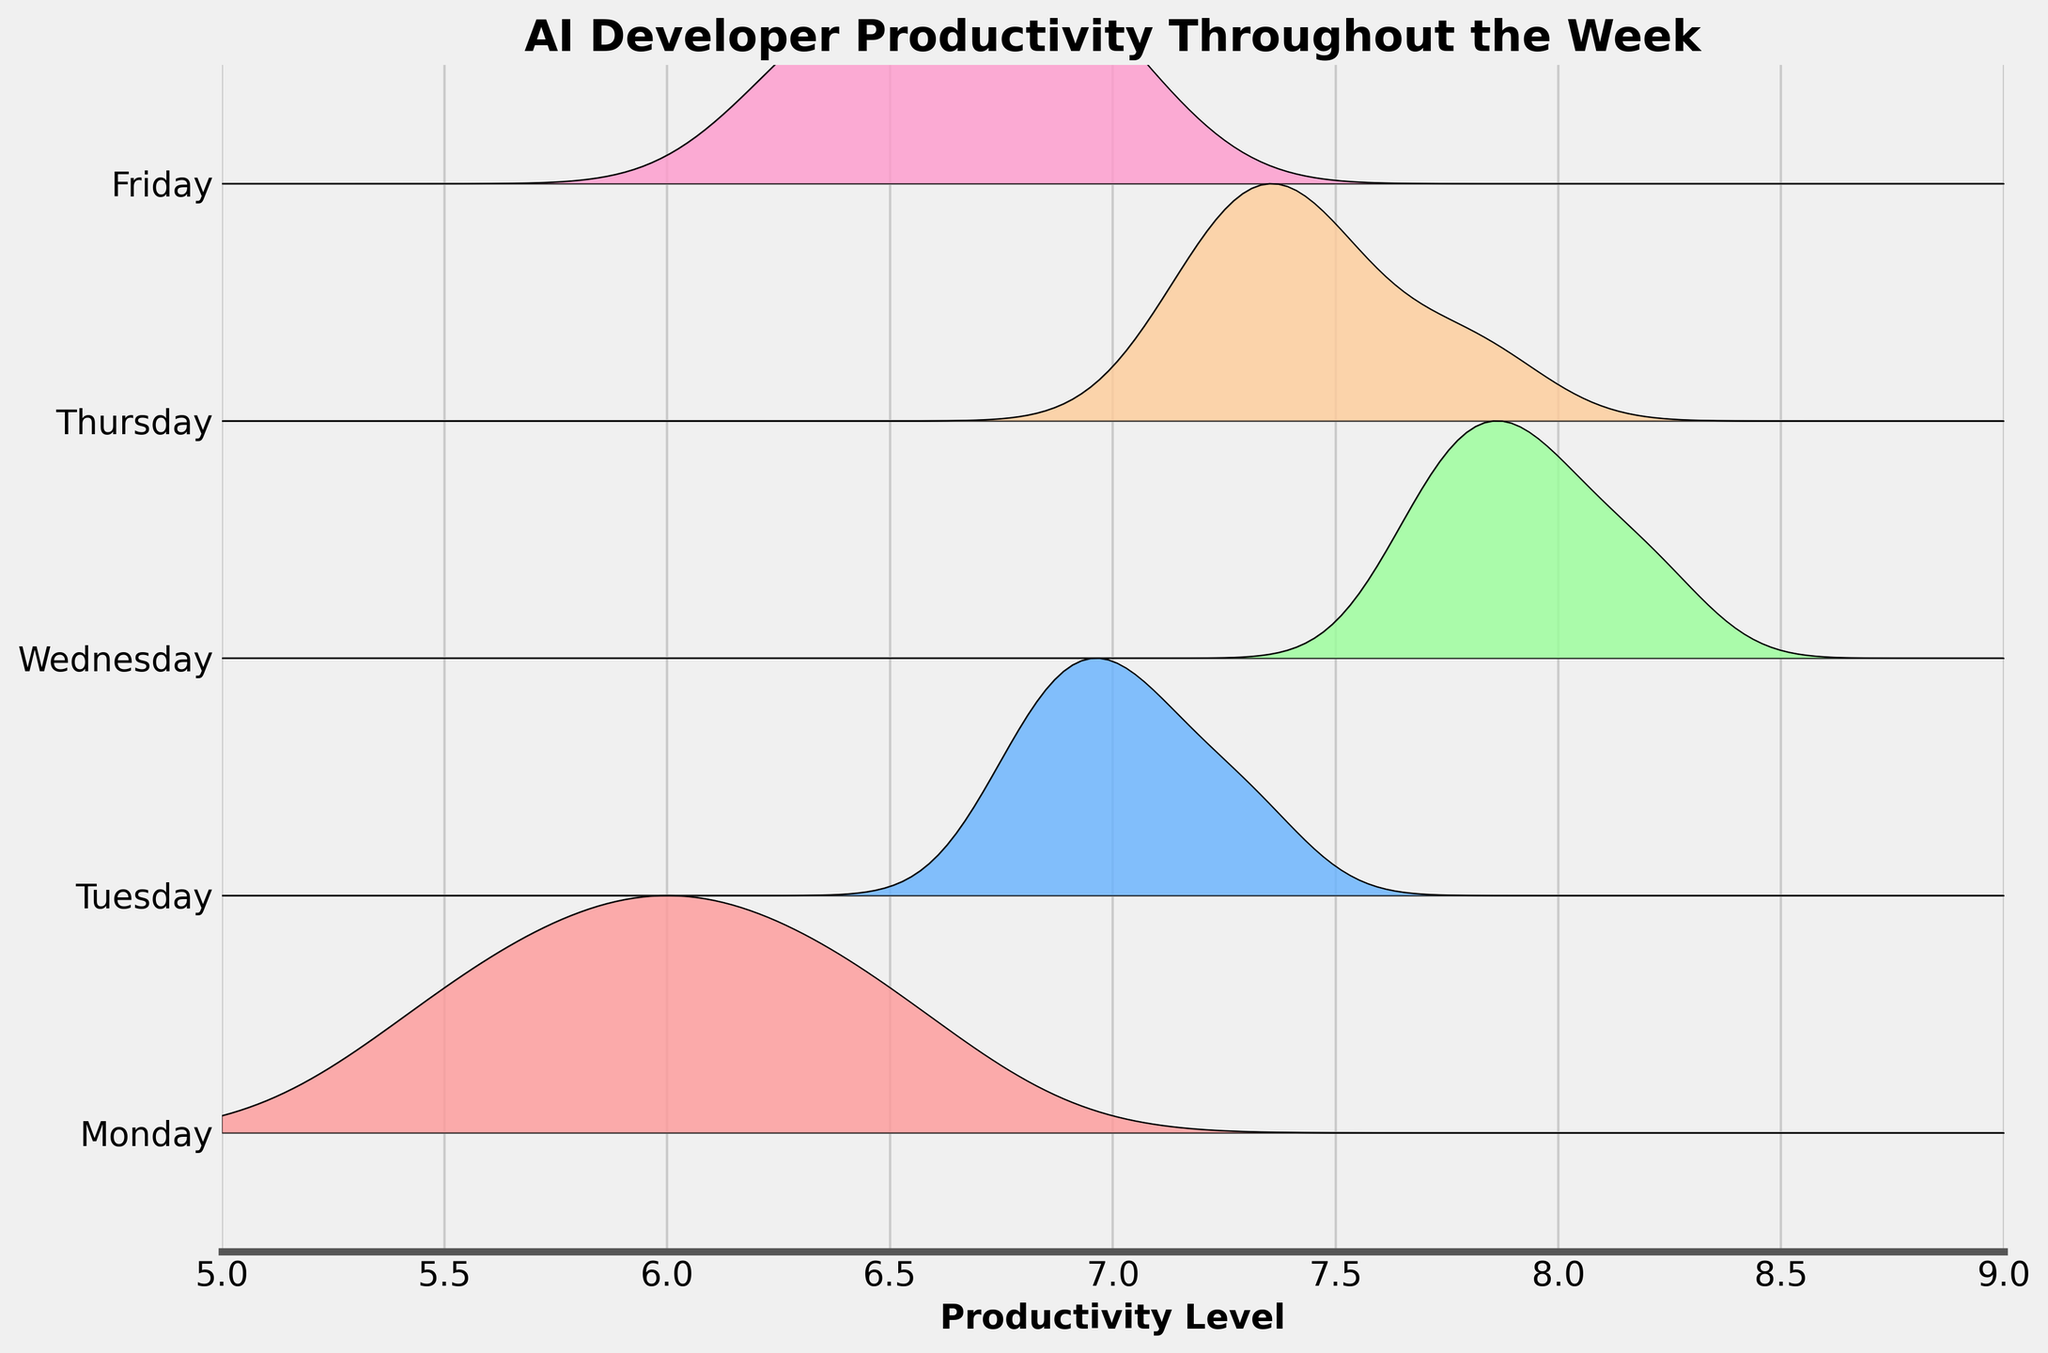What is the title of the Ridgeline plot? The title is displayed at the top of the figure, typically in a larger and bold font. It provides an overall description of what the plot represents.
Answer: AI Developer Productivity Throughout the Week What is the productivity level range represented on the x-axis? The x-axis ticks and limits define the range of productivity levels shown in the plot. Looking closely at these elements will give you the range.
Answer: 5 to 9 Which day shows the highest average productivity level? By observing the density curves and the peaks of the distributions for each day across the x-axis, we can determine which day has the overall highest productivity levels.
Answer: Wednesday What color represents the productivity levels on Tuesday? Each day is represented by a distinctive color in the plot. Looking for the color associated with the label "Tuesday" will give us the answer.
Answer: Blue (#66B2FF) Which day has the widest distribution of productivity levels? By comparing the spreads of the ridgeline plots for each day, you can determine which day has the widest range of productivity values, indicated by a broader curve.
Answer: Monday How does Friday's productivity compare to Monday's productivity? Examining the relative positions and spreads of the curves for Monday and Friday, we can compare their productivity levels. Monday's distribution appears earlier on the x-axis than Friday's.
Answer: Monday is generally lower than Friday What is the trend of average productivity from Monday to Friday? Observing the peak of the curves progressively from Monday to Friday, we can infer the trend of productivity throughout the week.
Answer: Productivity generally increases to Wednesday and then decreases towards Friday What day has the least overlap with other days in terms of productivity levels? By analyzing the density plots, we look for the curve that stands more distinctly alone without substantial overlap with other days' curves.
Answer: Wednesday What is the sharpest peak in any productivity distribution, and on what day does it occur? The sharpest peak corresponds to the highest density value of any day's curve. Identifying the day associated with this peak will provide the answer.
Answer: Wednesday Which days have similar productivity distribution shapes? By comparing the overall shapes of the curves for different days, we can identify those with similar patterns or peaks that align closely.
Answer: Tuesday and Thursday are similar 